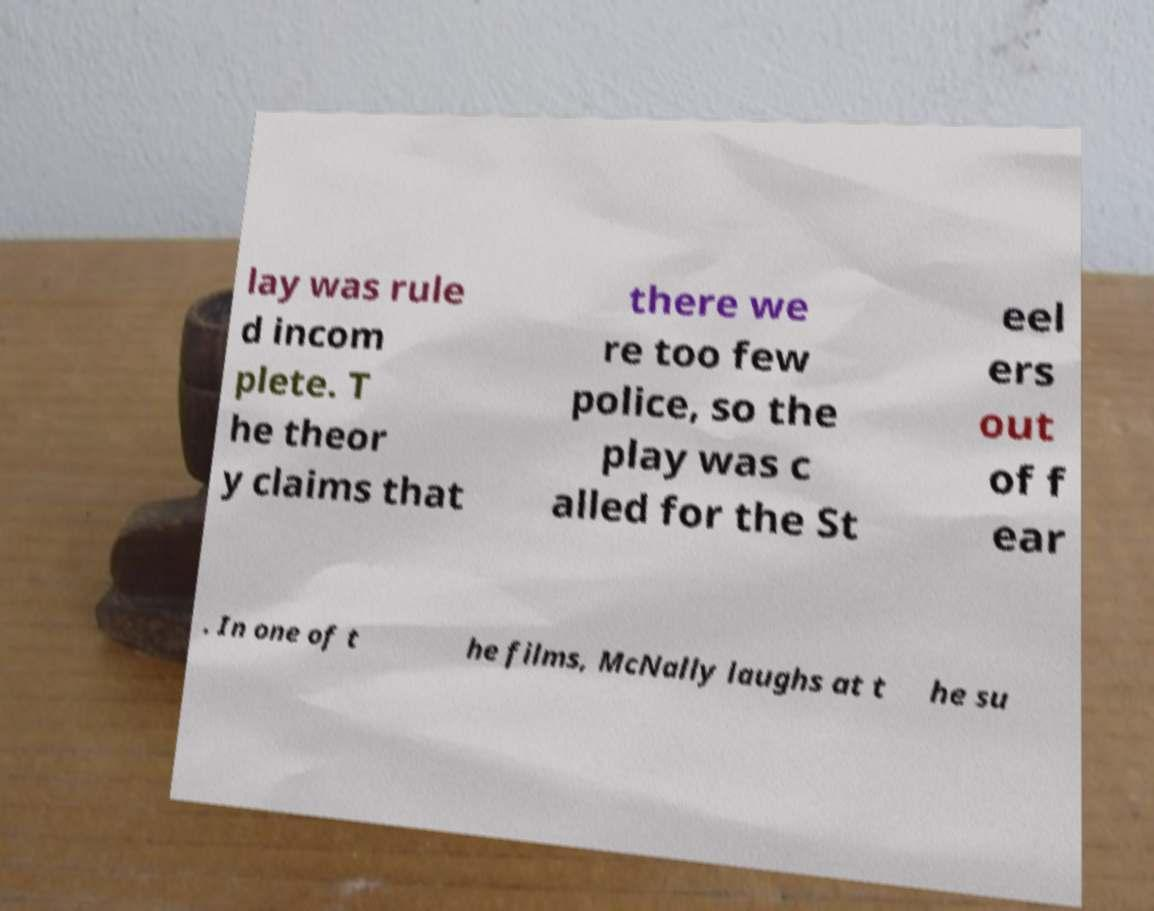Could you assist in decoding the text presented in this image and type it out clearly? lay was rule d incom plete. T he theor y claims that there we re too few police, so the play was c alled for the St eel ers out of f ear . In one of t he films, McNally laughs at t he su 